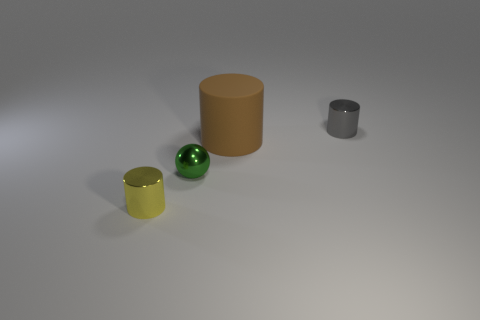Add 1 tiny gray metal blocks. How many objects exist? 5 Subtract all cylinders. How many objects are left? 1 Add 4 small blue things. How many small blue things exist? 4 Subtract 0 red spheres. How many objects are left? 4 Subtract all purple objects. Subtract all large brown objects. How many objects are left? 3 Add 1 small yellow objects. How many small yellow objects are left? 2 